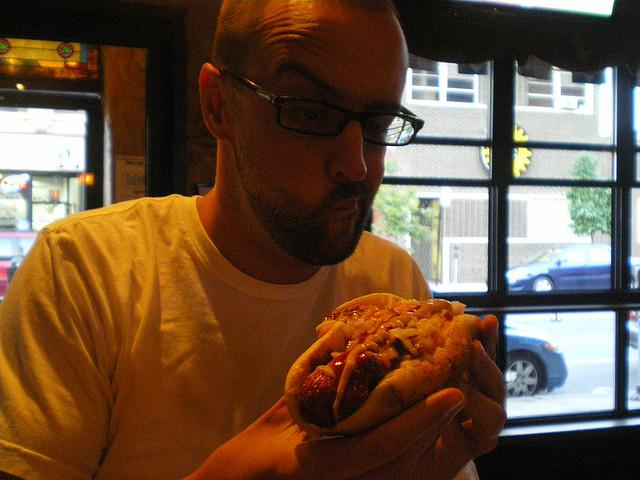Why does he have the huge sandwich? lunch 